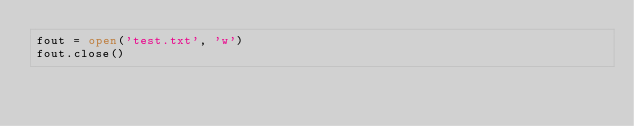<code> <loc_0><loc_0><loc_500><loc_500><_Python_>fout = open('test.txt', 'w')
fout.close()
</code> 